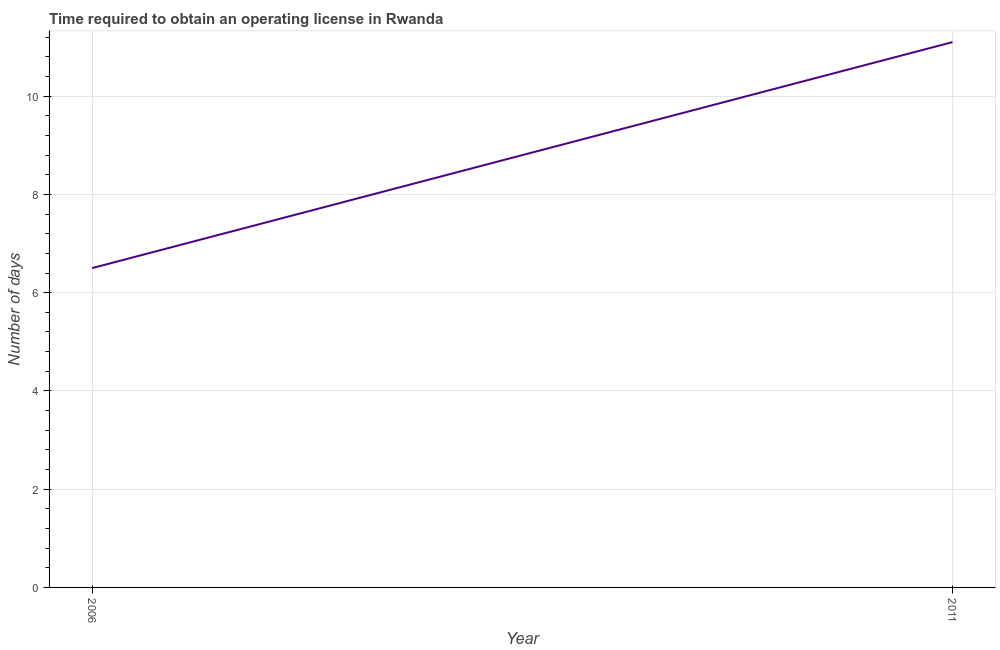What is the number of days to obtain operating license in 2006?
Keep it short and to the point. 6.5. Across all years, what is the maximum number of days to obtain operating license?
Give a very brief answer. 11.1. Across all years, what is the minimum number of days to obtain operating license?
Make the answer very short. 6.5. What is the sum of the number of days to obtain operating license?
Provide a succinct answer. 17.6. What is the difference between the number of days to obtain operating license in 2006 and 2011?
Offer a very short reply. -4.6. What is the average number of days to obtain operating license per year?
Ensure brevity in your answer.  8.8. What is the median number of days to obtain operating license?
Keep it short and to the point. 8.8. Do a majority of the years between 2006 and 2011 (inclusive) have number of days to obtain operating license greater than 5.6 days?
Ensure brevity in your answer.  Yes. What is the ratio of the number of days to obtain operating license in 2006 to that in 2011?
Ensure brevity in your answer.  0.59. Is the number of days to obtain operating license in 2006 less than that in 2011?
Ensure brevity in your answer.  Yes. How many lines are there?
Keep it short and to the point. 1. How many years are there in the graph?
Your answer should be compact. 2. Are the values on the major ticks of Y-axis written in scientific E-notation?
Provide a short and direct response. No. Does the graph contain any zero values?
Your answer should be compact. No. Does the graph contain grids?
Offer a terse response. Yes. What is the title of the graph?
Provide a short and direct response. Time required to obtain an operating license in Rwanda. What is the label or title of the X-axis?
Offer a terse response. Year. What is the label or title of the Y-axis?
Your answer should be compact. Number of days. What is the ratio of the Number of days in 2006 to that in 2011?
Your answer should be compact. 0.59. 